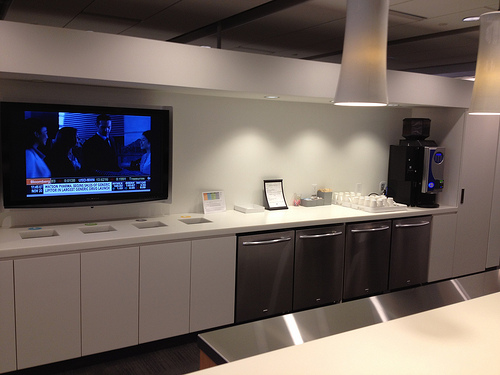Please provide a short description for this region: [0.45, 0.55, 0.86, 0.73]. This region shows four silver appliances positioned underneath the cabinet. 